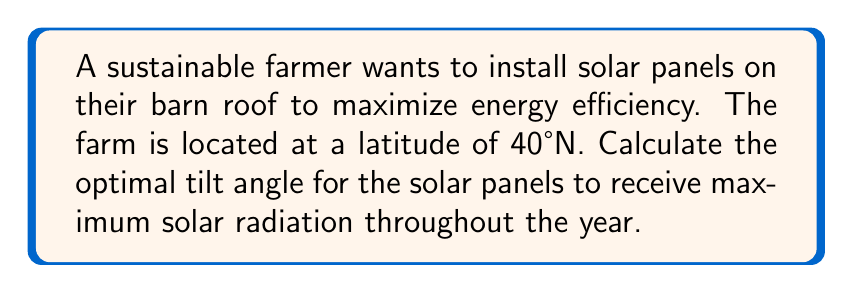Provide a solution to this math problem. To determine the optimal tilt angle for solar panels, we can use the following steps:

1. The general rule of thumb for fixed solar panels is that the optimal tilt angle is approximately equal to the latitude of the location.

2. In this case, the farm is located at 40°N latitude.

3. However, to account for seasonal variations and to optimize for year-round performance, we can use a more precise formula:

   $$ \text{Optimal Tilt Angle} = \text{Latitude} \times 0.76 + 3.1° $$

4. Plugging in the latitude:

   $$ \text{Optimal Tilt Angle} = 40° \times 0.76 + 3.1° $$

5. Calculate:
   $$ \text{Optimal Tilt Angle} = 30.4° + 3.1° = 33.5° $$

6. Round to the nearest whole degree:

   $$ \text{Optimal Tilt Angle} \approx 34° $$

[asy]
import geometry;

size(200);
draw((0,0)--(100,0),Arrow);
draw((0,0)--(0,100),Arrow);
draw((0,0)--(100,58),Arrow);

label("Ground", (50,-10));
label("Vertical", (-10,50));
label("Solar Panel", (70,40));

draw(arc((0,0),20,0,34),Arrow);
label("34°", (15,10));
[/asy]

This angle ensures that the solar panels receive optimal solar radiation throughout the year, balancing between summer and winter sun angles.
Answer: 34° 